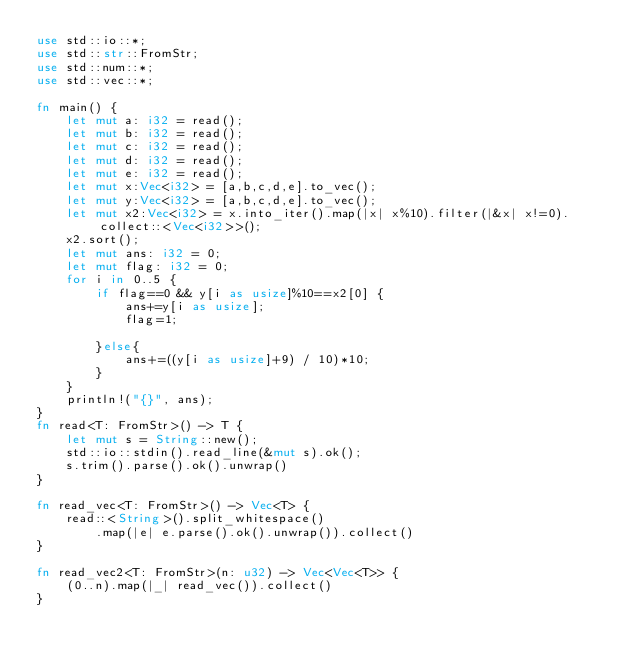Convert code to text. <code><loc_0><loc_0><loc_500><loc_500><_Rust_>use std::io::*;
use std::str::FromStr;
use std::num::*;
use std::vec::*;

fn main() {
    let mut a: i32 = read();
    let mut b: i32 = read();
    let mut c: i32 = read();
    let mut d: i32 = read();
    let mut e: i32 = read();
    let mut x:Vec<i32> = [a,b,c,d,e].to_vec();
    let mut y:Vec<i32> = [a,b,c,d,e].to_vec();
    let mut x2:Vec<i32> = x.into_iter().map(|x| x%10).filter(|&x| x!=0).collect::<Vec<i32>>();
    x2.sort();
    let mut ans: i32 = 0;
    let mut flag: i32 = 0;
    for i in 0..5 {
        if flag==0 && y[i as usize]%10==x2[0] {
            ans+=y[i as usize];
            flag=1;

        }else{
            ans+=((y[i as usize]+9) / 10)*10;
        }
    }
    println!("{}", ans);
}
fn read<T: FromStr>() -> T {
    let mut s = String::new();
    std::io::stdin().read_line(&mut s).ok();
    s.trim().parse().ok().unwrap()
}

fn read_vec<T: FromStr>() -> Vec<T> {
    read::<String>().split_whitespace()
        .map(|e| e.parse().ok().unwrap()).collect()
}

fn read_vec2<T: FromStr>(n: u32) -> Vec<Vec<T>> {
    (0..n).map(|_| read_vec()).collect()
}</code> 